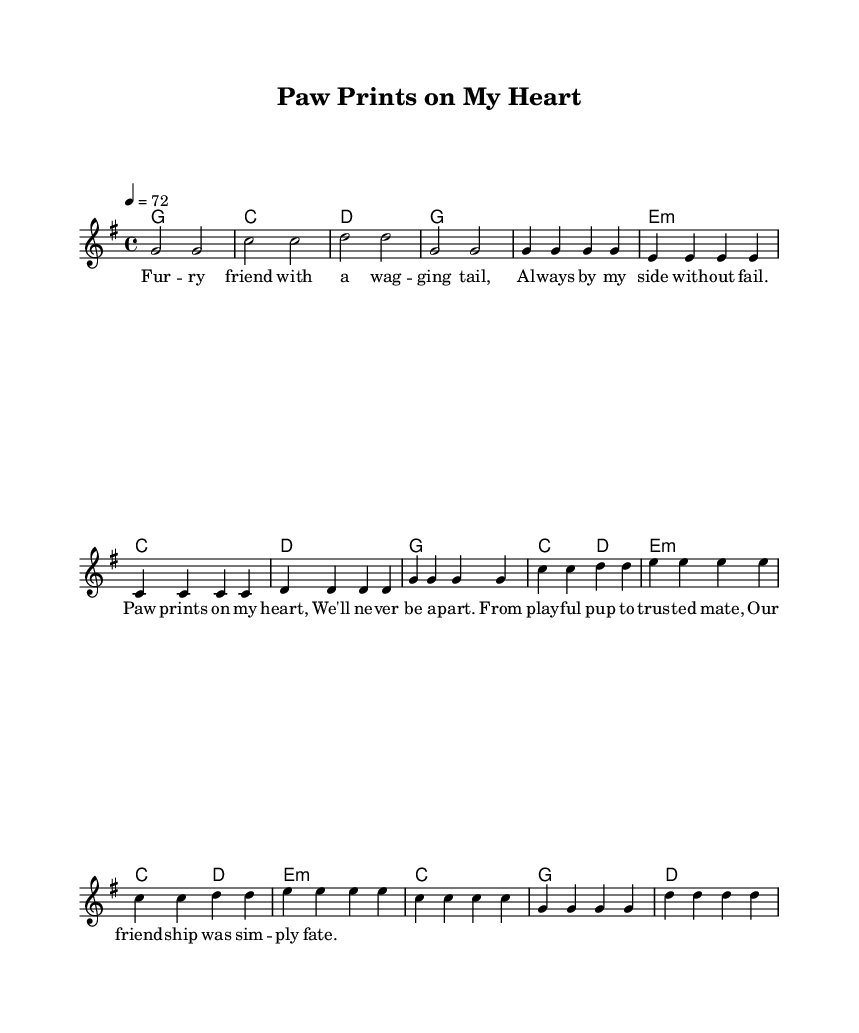What is the key signature of this music? The key signature is indicated by the absence of any sharps or flats at the beginning of the staff, which means it is set in G major.
Answer: G major What is the time signature of this music? The time signature is found next to the key signature and is indicated as 4/4, meaning there are four beats in each measure and a quarter note gets one beat.
Answer: 4/4 What is the tempo marking for this piece? The tempo marking is noted as "4 = 72," indicating that there are 72 beats per minute. This shows how fast the piece should be played.
Answer: 72 How many measures are in the chorus section? By counting the measures delineated for the chorus within the sheet music, we see that it spans four measures.
Answer: 4 What is the main theme of the lyrics? The lyrics emphasize a strong bond and companionship between the pet and its owner, indicated by lines such as "Paw prints on my heart."
Answer: Companionship What type of harmony is used throughout the piece? The harmony within the chords is primarily based on triads and is consistent with country music styles, using major and minor chords as indicated in the chord section.
Answer: Major and minor chords What does the bridge imply about the relationship described? The bridge reflects a deeper understanding and strong bond between the pet and owner, indicated by phrases like "Our friendship was simply fate."
Answer: Strong bond 